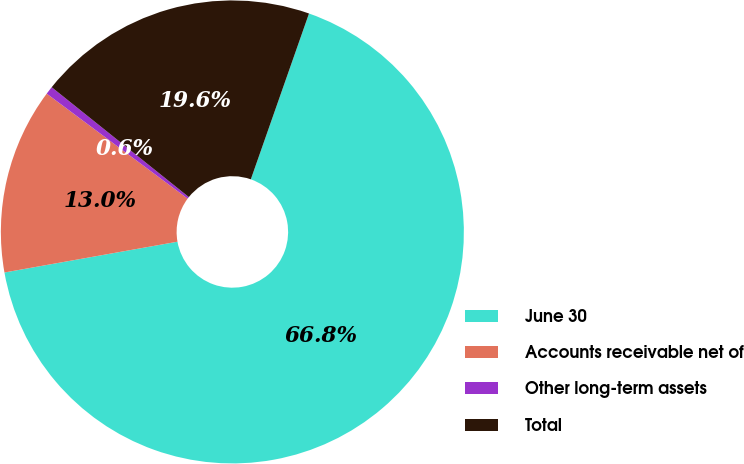<chart> <loc_0><loc_0><loc_500><loc_500><pie_chart><fcel>June 30<fcel>Accounts receivable net of<fcel>Other long-term assets<fcel>Total<nl><fcel>66.82%<fcel>12.99%<fcel>0.56%<fcel>19.62%<nl></chart> 